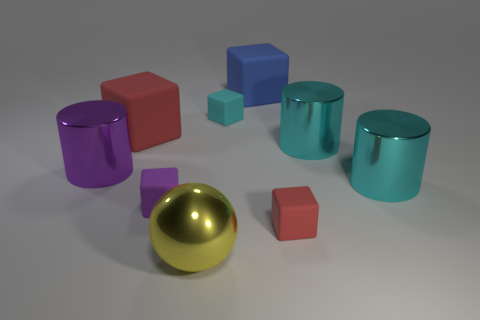Subtract all cyan cubes. How many cubes are left? 4 Subtract all large blue matte cubes. How many cubes are left? 4 Add 1 large cyan things. How many objects exist? 10 Subtract all gray blocks. Subtract all gray cylinders. How many blocks are left? 5 Subtract all cubes. How many objects are left? 4 Add 5 rubber blocks. How many rubber blocks exist? 10 Subtract 0 red cylinders. How many objects are left? 9 Subtract all big yellow balls. Subtract all tiny rubber cubes. How many objects are left? 5 Add 8 large matte objects. How many large matte objects are left? 10 